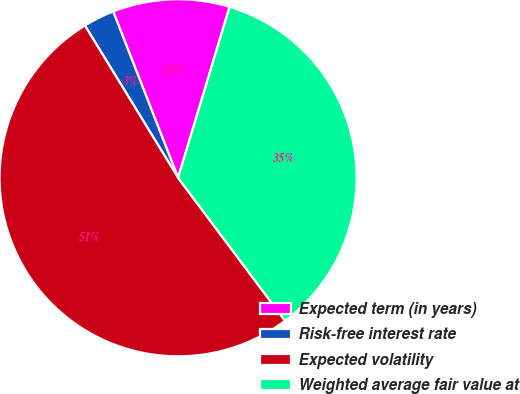Convert chart to OTSL. <chart><loc_0><loc_0><loc_500><loc_500><pie_chart><fcel>Expected term (in years)<fcel>Risk-free interest rate<fcel>Expected volatility<fcel>Weighted average fair value at<nl><fcel>10.58%<fcel>2.82%<fcel>51.49%<fcel>35.12%<nl></chart> 